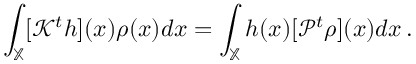<formula> <loc_0><loc_0><loc_500><loc_500>\int _ { \mathbb { X } } [ \mathcal { K } ^ { t } h ] ( x ) \rho ( x ) d x = \int _ { \mathbb { X } } h ( x ) [ \mathcal { P } ^ { t } \rho ] ( x ) d x \, .</formula> 